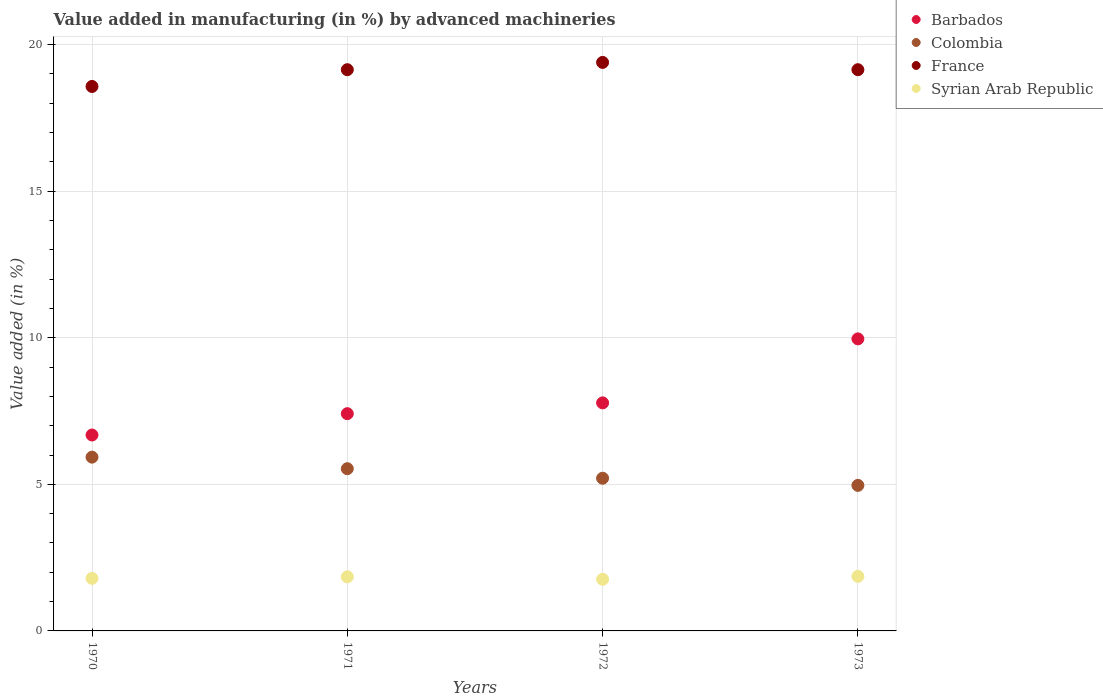How many different coloured dotlines are there?
Give a very brief answer. 4. Is the number of dotlines equal to the number of legend labels?
Your answer should be very brief. Yes. What is the percentage of value added in manufacturing by advanced machineries in Colombia in 1970?
Offer a terse response. 5.93. Across all years, what is the maximum percentage of value added in manufacturing by advanced machineries in Barbados?
Offer a very short reply. 9.96. Across all years, what is the minimum percentage of value added in manufacturing by advanced machineries in Barbados?
Offer a very short reply. 6.68. In which year was the percentage of value added in manufacturing by advanced machineries in Barbados maximum?
Provide a short and direct response. 1973. What is the total percentage of value added in manufacturing by advanced machineries in Syrian Arab Republic in the graph?
Make the answer very short. 7.26. What is the difference between the percentage of value added in manufacturing by advanced machineries in France in 1970 and that in 1971?
Offer a terse response. -0.57. What is the difference between the percentage of value added in manufacturing by advanced machineries in Colombia in 1973 and the percentage of value added in manufacturing by advanced machineries in Syrian Arab Republic in 1972?
Your answer should be compact. 3.2. What is the average percentage of value added in manufacturing by advanced machineries in Syrian Arab Republic per year?
Your answer should be compact. 1.82. In the year 1971, what is the difference between the percentage of value added in manufacturing by advanced machineries in France and percentage of value added in manufacturing by advanced machineries in Barbados?
Provide a succinct answer. 11.73. What is the ratio of the percentage of value added in manufacturing by advanced machineries in Syrian Arab Republic in 1971 to that in 1972?
Provide a succinct answer. 1.05. Is the percentage of value added in manufacturing by advanced machineries in Syrian Arab Republic in 1971 less than that in 1973?
Provide a short and direct response. Yes. What is the difference between the highest and the second highest percentage of value added in manufacturing by advanced machineries in France?
Keep it short and to the point. 0.25. What is the difference between the highest and the lowest percentage of value added in manufacturing by advanced machineries in Barbados?
Provide a short and direct response. 3.28. In how many years, is the percentage of value added in manufacturing by advanced machineries in Barbados greater than the average percentage of value added in manufacturing by advanced machineries in Barbados taken over all years?
Keep it short and to the point. 1. Is it the case that in every year, the sum of the percentage of value added in manufacturing by advanced machineries in Barbados and percentage of value added in manufacturing by advanced machineries in Syrian Arab Republic  is greater than the sum of percentage of value added in manufacturing by advanced machineries in Colombia and percentage of value added in manufacturing by advanced machineries in France?
Your answer should be very brief. No. Does the percentage of value added in manufacturing by advanced machineries in Syrian Arab Republic monotonically increase over the years?
Provide a succinct answer. No. Does the graph contain any zero values?
Your answer should be compact. No. How many legend labels are there?
Offer a very short reply. 4. How are the legend labels stacked?
Your answer should be compact. Vertical. What is the title of the graph?
Give a very brief answer. Value added in manufacturing (in %) by advanced machineries. What is the label or title of the X-axis?
Keep it short and to the point. Years. What is the label or title of the Y-axis?
Your answer should be very brief. Value added (in %). What is the Value added (in %) in Barbados in 1970?
Give a very brief answer. 6.68. What is the Value added (in %) of Colombia in 1970?
Offer a very short reply. 5.93. What is the Value added (in %) in France in 1970?
Provide a short and direct response. 18.57. What is the Value added (in %) of Syrian Arab Republic in 1970?
Your answer should be very brief. 1.79. What is the Value added (in %) of Barbados in 1971?
Make the answer very short. 7.41. What is the Value added (in %) in Colombia in 1971?
Ensure brevity in your answer.  5.53. What is the Value added (in %) of France in 1971?
Offer a very short reply. 19.14. What is the Value added (in %) of Syrian Arab Republic in 1971?
Give a very brief answer. 1.85. What is the Value added (in %) in Barbados in 1972?
Your answer should be compact. 7.78. What is the Value added (in %) of Colombia in 1972?
Ensure brevity in your answer.  5.21. What is the Value added (in %) of France in 1972?
Ensure brevity in your answer.  19.39. What is the Value added (in %) in Syrian Arab Republic in 1972?
Keep it short and to the point. 1.76. What is the Value added (in %) of Barbados in 1973?
Your answer should be compact. 9.96. What is the Value added (in %) of Colombia in 1973?
Ensure brevity in your answer.  4.96. What is the Value added (in %) in France in 1973?
Your answer should be compact. 19.14. What is the Value added (in %) in Syrian Arab Republic in 1973?
Provide a short and direct response. 1.86. Across all years, what is the maximum Value added (in %) in Barbados?
Offer a very short reply. 9.96. Across all years, what is the maximum Value added (in %) in Colombia?
Offer a very short reply. 5.93. Across all years, what is the maximum Value added (in %) in France?
Provide a succinct answer. 19.39. Across all years, what is the maximum Value added (in %) in Syrian Arab Republic?
Offer a very short reply. 1.86. Across all years, what is the minimum Value added (in %) in Barbados?
Offer a terse response. 6.68. Across all years, what is the minimum Value added (in %) of Colombia?
Ensure brevity in your answer.  4.96. Across all years, what is the minimum Value added (in %) of France?
Your answer should be very brief. 18.57. Across all years, what is the minimum Value added (in %) of Syrian Arab Republic?
Provide a short and direct response. 1.76. What is the total Value added (in %) in Barbados in the graph?
Offer a terse response. 31.83. What is the total Value added (in %) in Colombia in the graph?
Provide a succinct answer. 21.63. What is the total Value added (in %) of France in the graph?
Your response must be concise. 76.25. What is the total Value added (in %) in Syrian Arab Republic in the graph?
Offer a terse response. 7.26. What is the difference between the Value added (in %) in Barbados in 1970 and that in 1971?
Give a very brief answer. -0.73. What is the difference between the Value added (in %) in Colombia in 1970 and that in 1971?
Provide a succinct answer. 0.39. What is the difference between the Value added (in %) of France in 1970 and that in 1971?
Your answer should be compact. -0.57. What is the difference between the Value added (in %) of Syrian Arab Republic in 1970 and that in 1971?
Make the answer very short. -0.05. What is the difference between the Value added (in %) of Barbados in 1970 and that in 1972?
Give a very brief answer. -1.1. What is the difference between the Value added (in %) in Colombia in 1970 and that in 1972?
Your answer should be compact. 0.72. What is the difference between the Value added (in %) of France in 1970 and that in 1972?
Keep it short and to the point. -0.82. What is the difference between the Value added (in %) in Syrian Arab Republic in 1970 and that in 1972?
Offer a terse response. 0.03. What is the difference between the Value added (in %) in Barbados in 1970 and that in 1973?
Provide a succinct answer. -3.28. What is the difference between the Value added (in %) of Colombia in 1970 and that in 1973?
Give a very brief answer. 0.96. What is the difference between the Value added (in %) of France in 1970 and that in 1973?
Give a very brief answer. -0.57. What is the difference between the Value added (in %) of Syrian Arab Republic in 1970 and that in 1973?
Your response must be concise. -0.07. What is the difference between the Value added (in %) in Barbados in 1971 and that in 1972?
Offer a terse response. -0.37. What is the difference between the Value added (in %) in Colombia in 1971 and that in 1972?
Provide a short and direct response. 0.32. What is the difference between the Value added (in %) in France in 1971 and that in 1972?
Keep it short and to the point. -0.25. What is the difference between the Value added (in %) of Syrian Arab Republic in 1971 and that in 1972?
Provide a succinct answer. 0.08. What is the difference between the Value added (in %) of Barbados in 1971 and that in 1973?
Provide a short and direct response. -2.55. What is the difference between the Value added (in %) in Colombia in 1971 and that in 1973?
Your answer should be very brief. 0.57. What is the difference between the Value added (in %) of Syrian Arab Republic in 1971 and that in 1973?
Your answer should be very brief. -0.01. What is the difference between the Value added (in %) in Barbados in 1972 and that in 1973?
Give a very brief answer. -2.18. What is the difference between the Value added (in %) in Colombia in 1972 and that in 1973?
Provide a short and direct response. 0.24. What is the difference between the Value added (in %) in France in 1972 and that in 1973?
Offer a very short reply. 0.25. What is the difference between the Value added (in %) in Syrian Arab Republic in 1972 and that in 1973?
Offer a terse response. -0.1. What is the difference between the Value added (in %) in Barbados in 1970 and the Value added (in %) in Colombia in 1971?
Your answer should be very brief. 1.15. What is the difference between the Value added (in %) of Barbados in 1970 and the Value added (in %) of France in 1971?
Provide a short and direct response. -12.46. What is the difference between the Value added (in %) of Barbados in 1970 and the Value added (in %) of Syrian Arab Republic in 1971?
Your answer should be compact. 4.84. What is the difference between the Value added (in %) in Colombia in 1970 and the Value added (in %) in France in 1971?
Provide a short and direct response. -13.22. What is the difference between the Value added (in %) of Colombia in 1970 and the Value added (in %) of Syrian Arab Republic in 1971?
Keep it short and to the point. 4.08. What is the difference between the Value added (in %) in France in 1970 and the Value added (in %) in Syrian Arab Republic in 1971?
Offer a very short reply. 16.73. What is the difference between the Value added (in %) in Barbados in 1970 and the Value added (in %) in Colombia in 1972?
Ensure brevity in your answer.  1.47. What is the difference between the Value added (in %) in Barbados in 1970 and the Value added (in %) in France in 1972?
Provide a succinct answer. -12.71. What is the difference between the Value added (in %) in Barbados in 1970 and the Value added (in %) in Syrian Arab Republic in 1972?
Offer a terse response. 4.92. What is the difference between the Value added (in %) of Colombia in 1970 and the Value added (in %) of France in 1972?
Offer a very short reply. -13.46. What is the difference between the Value added (in %) of Colombia in 1970 and the Value added (in %) of Syrian Arab Republic in 1972?
Your answer should be compact. 4.17. What is the difference between the Value added (in %) of France in 1970 and the Value added (in %) of Syrian Arab Republic in 1972?
Provide a short and direct response. 16.81. What is the difference between the Value added (in %) in Barbados in 1970 and the Value added (in %) in Colombia in 1973?
Provide a succinct answer. 1.72. What is the difference between the Value added (in %) of Barbados in 1970 and the Value added (in %) of France in 1973?
Your response must be concise. -12.46. What is the difference between the Value added (in %) of Barbados in 1970 and the Value added (in %) of Syrian Arab Republic in 1973?
Offer a very short reply. 4.82. What is the difference between the Value added (in %) in Colombia in 1970 and the Value added (in %) in France in 1973?
Keep it short and to the point. -13.22. What is the difference between the Value added (in %) in Colombia in 1970 and the Value added (in %) in Syrian Arab Republic in 1973?
Give a very brief answer. 4.07. What is the difference between the Value added (in %) in France in 1970 and the Value added (in %) in Syrian Arab Republic in 1973?
Offer a terse response. 16.71. What is the difference between the Value added (in %) in Barbados in 1971 and the Value added (in %) in Colombia in 1972?
Give a very brief answer. 2.2. What is the difference between the Value added (in %) of Barbados in 1971 and the Value added (in %) of France in 1972?
Provide a succinct answer. -11.98. What is the difference between the Value added (in %) of Barbados in 1971 and the Value added (in %) of Syrian Arab Republic in 1972?
Offer a terse response. 5.65. What is the difference between the Value added (in %) of Colombia in 1971 and the Value added (in %) of France in 1972?
Your response must be concise. -13.86. What is the difference between the Value added (in %) of Colombia in 1971 and the Value added (in %) of Syrian Arab Republic in 1972?
Your answer should be compact. 3.77. What is the difference between the Value added (in %) of France in 1971 and the Value added (in %) of Syrian Arab Republic in 1972?
Your response must be concise. 17.38. What is the difference between the Value added (in %) of Barbados in 1971 and the Value added (in %) of Colombia in 1973?
Your response must be concise. 2.45. What is the difference between the Value added (in %) of Barbados in 1971 and the Value added (in %) of France in 1973?
Offer a terse response. -11.73. What is the difference between the Value added (in %) in Barbados in 1971 and the Value added (in %) in Syrian Arab Republic in 1973?
Make the answer very short. 5.55. What is the difference between the Value added (in %) in Colombia in 1971 and the Value added (in %) in France in 1973?
Keep it short and to the point. -13.61. What is the difference between the Value added (in %) of Colombia in 1971 and the Value added (in %) of Syrian Arab Republic in 1973?
Provide a short and direct response. 3.67. What is the difference between the Value added (in %) in France in 1971 and the Value added (in %) in Syrian Arab Republic in 1973?
Provide a short and direct response. 17.28. What is the difference between the Value added (in %) of Barbados in 1972 and the Value added (in %) of Colombia in 1973?
Your response must be concise. 2.81. What is the difference between the Value added (in %) of Barbados in 1972 and the Value added (in %) of France in 1973?
Provide a short and direct response. -11.36. What is the difference between the Value added (in %) of Barbados in 1972 and the Value added (in %) of Syrian Arab Republic in 1973?
Make the answer very short. 5.92. What is the difference between the Value added (in %) in Colombia in 1972 and the Value added (in %) in France in 1973?
Your answer should be very brief. -13.94. What is the difference between the Value added (in %) in Colombia in 1972 and the Value added (in %) in Syrian Arab Republic in 1973?
Give a very brief answer. 3.35. What is the difference between the Value added (in %) in France in 1972 and the Value added (in %) in Syrian Arab Republic in 1973?
Ensure brevity in your answer.  17.53. What is the average Value added (in %) in Barbados per year?
Provide a short and direct response. 7.96. What is the average Value added (in %) of Colombia per year?
Make the answer very short. 5.41. What is the average Value added (in %) in France per year?
Provide a short and direct response. 19.06. What is the average Value added (in %) of Syrian Arab Republic per year?
Make the answer very short. 1.82. In the year 1970, what is the difference between the Value added (in %) of Barbados and Value added (in %) of Colombia?
Your answer should be very brief. 0.76. In the year 1970, what is the difference between the Value added (in %) in Barbados and Value added (in %) in France?
Your answer should be very brief. -11.89. In the year 1970, what is the difference between the Value added (in %) in Barbados and Value added (in %) in Syrian Arab Republic?
Your response must be concise. 4.89. In the year 1970, what is the difference between the Value added (in %) in Colombia and Value added (in %) in France?
Provide a succinct answer. -12.64. In the year 1970, what is the difference between the Value added (in %) of Colombia and Value added (in %) of Syrian Arab Republic?
Provide a succinct answer. 4.13. In the year 1970, what is the difference between the Value added (in %) of France and Value added (in %) of Syrian Arab Republic?
Offer a terse response. 16.78. In the year 1971, what is the difference between the Value added (in %) in Barbados and Value added (in %) in Colombia?
Keep it short and to the point. 1.88. In the year 1971, what is the difference between the Value added (in %) of Barbados and Value added (in %) of France?
Keep it short and to the point. -11.73. In the year 1971, what is the difference between the Value added (in %) of Barbados and Value added (in %) of Syrian Arab Republic?
Your answer should be compact. 5.56. In the year 1971, what is the difference between the Value added (in %) of Colombia and Value added (in %) of France?
Make the answer very short. -13.61. In the year 1971, what is the difference between the Value added (in %) in Colombia and Value added (in %) in Syrian Arab Republic?
Ensure brevity in your answer.  3.69. In the year 1971, what is the difference between the Value added (in %) in France and Value added (in %) in Syrian Arab Republic?
Provide a short and direct response. 17.3. In the year 1972, what is the difference between the Value added (in %) in Barbados and Value added (in %) in Colombia?
Your answer should be very brief. 2.57. In the year 1972, what is the difference between the Value added (in %) in Barbados and Value added (in %) in France?
Make the answer very short. -11.61. In the year 1972, what is the difference between the Value added (in %) in Barbados and Value added (in %) in Syrian Arab Republic?
Make the answer very short. 6.02. In the year 1972, what is the difference between the Value added (in %) of Colombia and Value added (in %) of France?
Ensure brevity in your answer.  -14.18. In the year 1972, what is the difference between the Value added (in %) in Colombia and Value added (in %) in Syrian Arab Republic?
Provide a succinct answer. 3.45. In the year 1972, what is the difference between the Value added (in %) of France and Value added (in %) of Syrian Arab Republic?
Your answer should be compact. 17.63. In the year 1973, what is the difference between the Value added (in %) in Barbados and Value added (in %) in Colombia?
Give a very brief answer. 5. In the year 1973, what is the difference between the Value added (in %) of Barbados and Value added (in %) of France?
Offer a terse response. -9.18. In the year 1973, what is the difference between the Value added (in %) in Barbados and Value added (in %) in Syrian Arab Republic?
Provide a succinct answer. 8.1. In the year 1973, what is the difference between the Value added (in %) of Colombia and Value added (in %) of France?
Offer a very short reply. -14.18. In the year 1973, what is the difference between the Value added (in %) in Colombia and Value added (in %) in Syrian Arab Republic?
Offer a very short reply. 3.1. In the year 1973, what is the difference between the Value added (in %) in France and Value added (in %) in Syrian Arab Republic?
Offer a terse response. 17.28. What is the ratio of the Value added (in %) of Barbados in 1970 to that in 1971?
Provide a succinct answer. 0.9. What is the ratio of the Value added (in %) in Colombia in 1970 to that in 1971?
Provide a short and direct response. 1.07. What is the ratio of the Value added (in %) in France in 1970 to that in 1971?
Keep it short and to the point. 0.97. What is the ratio of the Value added (in %) of Syrian Arab Republic in 1970 to that in 1971?
Keep it short and to the point. 0.97. What is the ratio of the Value added (in %) of Barbados in 1970 to that in 1972?
Make the answer very short. 0.86. What is the ratio of the Value added (in %) in Colombia in 1970 to that in 1972?
Provide a succinct answer. 1.14. What is the ratio of the Value added (in %) of France in 1970 to that in 1972?
Give a very brief answer. 0.96. What is the ratio of the Value added (in %) in Syrian Arab Republic in 1970 to that in 1972?
Provide a succinct answer. 1.02. What is the ratio of the Value added (in %) of Barbados in 1970 to that in 1973?
Your answer should be compact. 0.67. What is the ratio of the Value added (in %) in Colombia in 1970 to that in 1973?
Your answer should be compact. 1.19. What is the ratio of the Value added (in %) of France in 1970 to that in 1973?
Make the answer very short. 0.97. What is the ratio of the Value added (in %) of Syrian Arab Republic in 1970 to that in 1973?
Your response must be concise. 0.96. What is the ratio of the Value added (in %) of Barbados in 1971 to that in 1972?
Keep it short and to the point. 0.95. What is the ratio of the Value added (in %) in Colombia in 1971 to that in 1972?
Provide a short and direct response. 1.06. What is the ratio of the Value added (in %) in France in 1971 to that in 1972?
Make the answer very short. 0.99. What is the ratio of the Value added (in %) in Syrian Arab Republic in 1971 to that in 1972?
Ensure brevity in your answer.  1.05. What is the ratio of the Value added (in %) in Barbados in 1971 to that in 1973?
Your answer should be very brief. 0.74. What is the ratio of the Value added (in %) of Colombia in 1971 to that in 1973?
Give a very brief answer. 1.11. What is the ratio of the Value added (in %) of Barbados in 1972 to that in 1973?
Keep it short and to the point. 0.78. What is the ratio of the Value added (in %) in Colombia in 1972 to that in 1973?
Offer a terse response. 1.05. What is the ratio of the Value added (in %) in Syrian Arab Republic in 1972 to that in 1973?
Offer a terse response. 0.95. What is the difference between the highest and the second highest Value added (in %) of Barbados?
Offer a very short reply. 2.18. What is the difference between the highest and the second highest Value added (in %) of Colombia?
Your answer should be very brief. 0.39. What is the difference between the highest and the second highest Value added (in %) of France?
Your answer should be compact. 0.25. What is the difference between the highest and the second highest Value added (in %) of Syrian Arab Republic?
Provide a short and direct response. 0.01. What is the difference between the highest and the lowest Value added (in %) in Barbados?
Keep it short and to the point. 3.28. What is the difference between the highest and the lowest Value added (in %) in Colombia?
Your answer should be compact. 0.96. What is the difference between the highest and the lowest Value added (in %) of France?
Provide a succinct answer. 0.82. What is the difference between the highest and the lowest Value added (in %) in Syrian Arab Republic?
Keep it short and to the point. 0.1. 